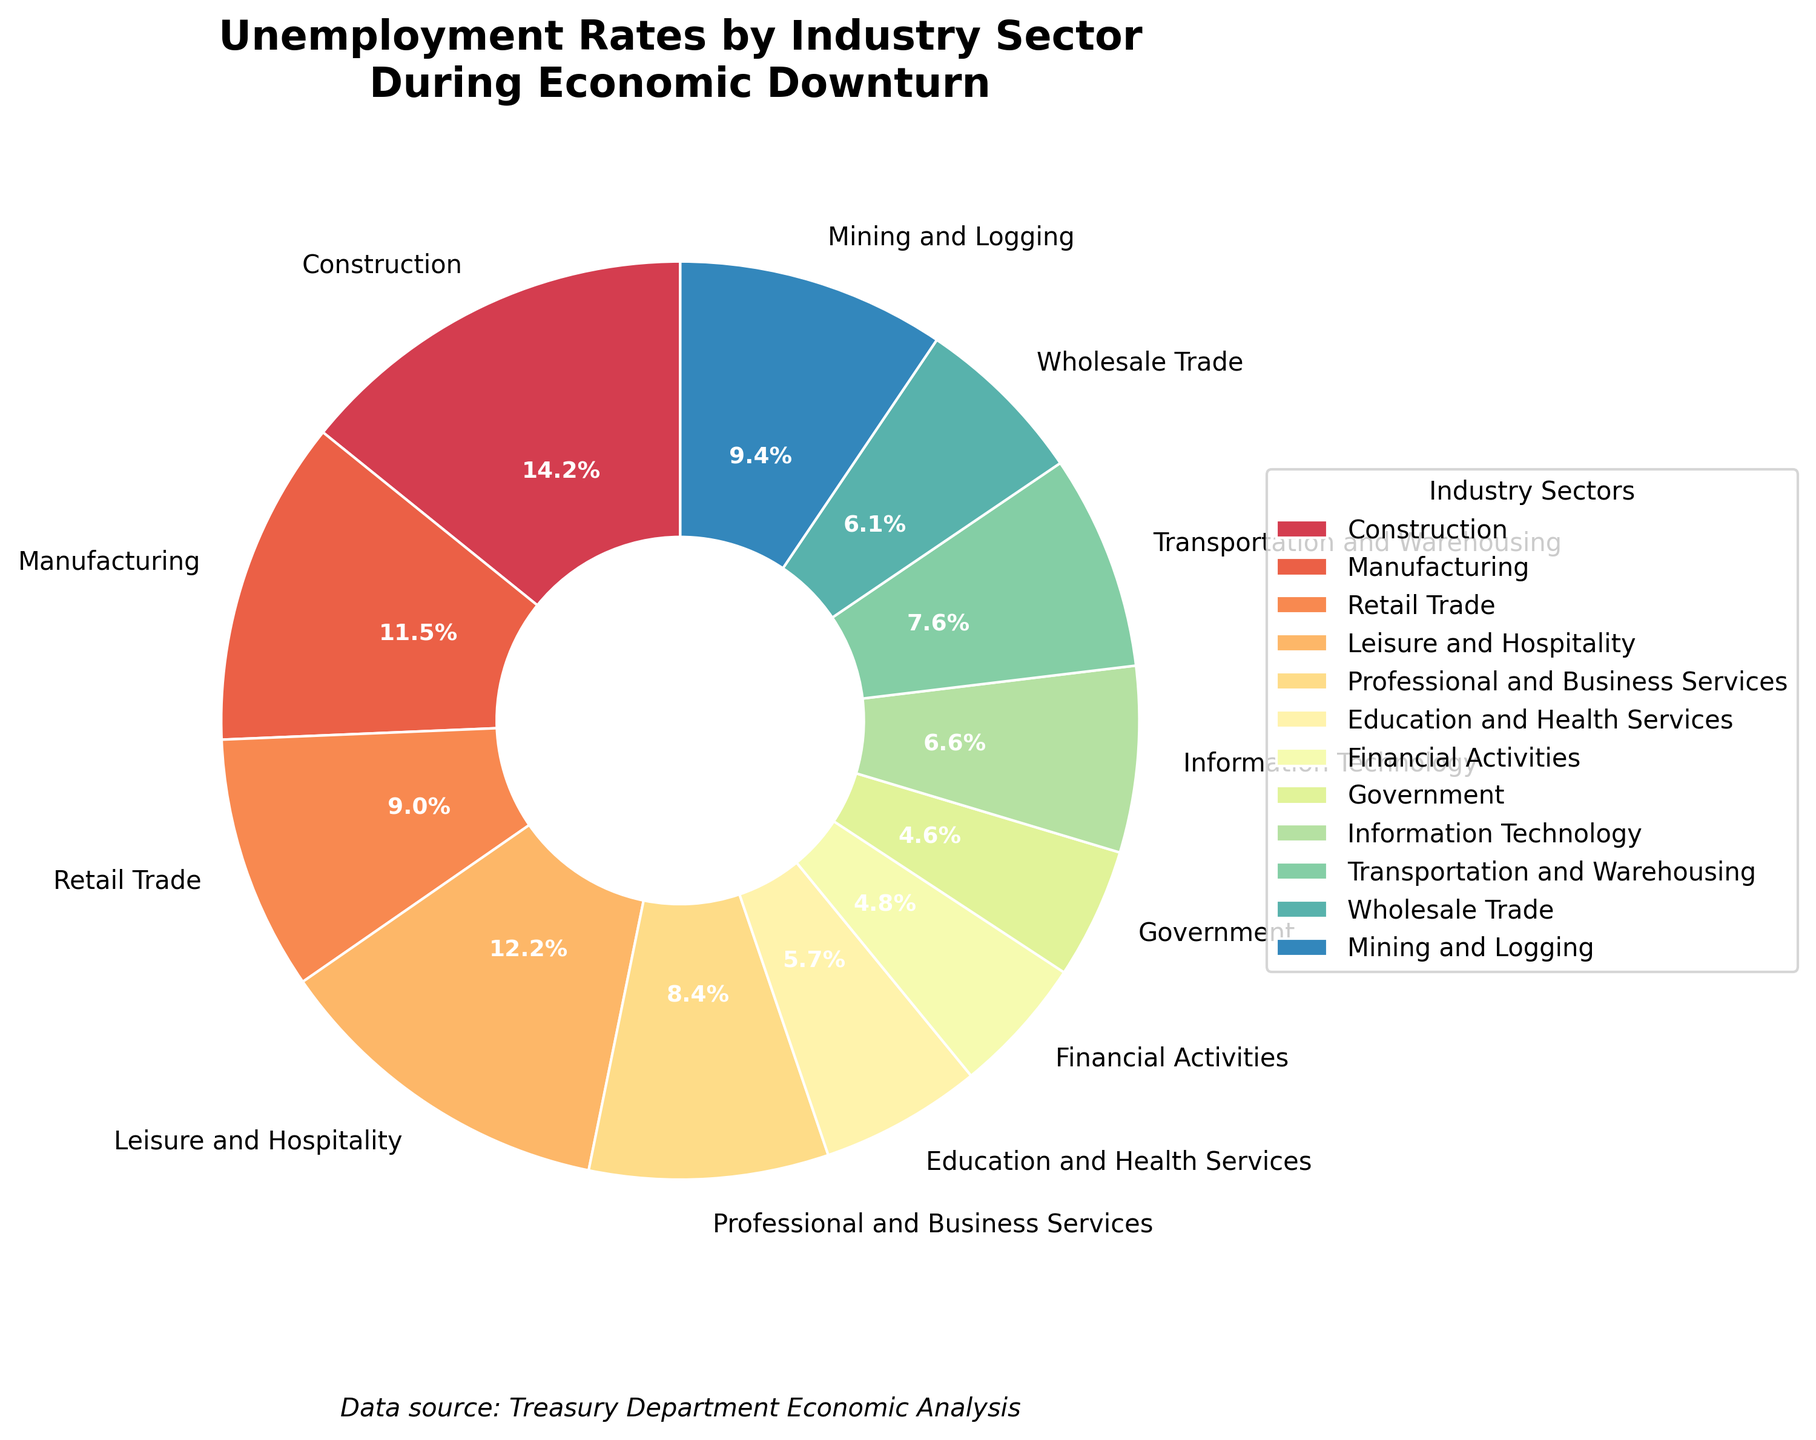What industry sector has the highest unemployment rate? Look at the pie chart and find the sector with the largest percentage. Construction has an 18.2% unemployment rate, which is the highest.
Answer: Construction What is the combined unemployment rate of the sectors with rates lower than 10%? Identify the sectors with unemployment rates lower than 10%: Education and Health Services (7.3%), Financial Activities (6.2%), Government (5.9%), Information Technology (8.4%), Transportation and Warehousing (9.7%), Wholesale Trade (7.8%). Add these rates: 7.3% + 6.2% + 5.9% + 8.4% + 9.7% + 7.8% = 45.3%.
Answer: 45.3% Which sector has the smallest wedge in the pie chart? By visual inspection, the smallest wedge corresponds to the sector with the lowest percentage. Government has a 5.9% unemployment rate, which is the smallest.
Answer: Government Compare the unemployment rates of Manufacturing and Retail Trade. Which one has a higher rate and by how much? Manufacturing has an unemployment rate of 14.7%, while Retail Trade has 11.5%. The difference is 14.7% - 11.5% = 3.2%.
Answer: Manufacturing has a higher rate by 3.2% Which sectors have an unemployment rate higher than the average rate across all sectors? Calculate the average rate by summing all rates and dividing by the number of sectors: (18.2 + 14.7 + 11.5 + 15.6 + 10.8 + 7.3 + 6.2 + 5.9 + 8.4 + 9.7 + 7.8 + 12.1) / 12 = 11.08%. Next, identify sectors with rates higher than 11.08%. They are: Construction (18.2%), Manufacturing (14.7%), Retail Trade (11.5%), Leisure and Hospitality (15.6%), Mining and Logging (12.1%).
Answer: Construction, Manufacturing, Retail Trade, Leisure and Hospitality, Mining and Logging How does the unemployment rate in Financial Activities compare to that in Education and Health Services? Financial Activities has an unemployment rate of 6.2%, and Education and Health Services has 7.3%. Therefore, Financial Activities has a lower unemployment rate by 7.3% - 6.2% = 1.1%.
Answer: Financial Activities is lower by 1.1% Which sector represents approximately one-tenth of the pie chart? One-tenth of the pie chart corresponds to 10%. Professional and Business Services has an unemployment rate of 10.8%, which is close to this proportion.
Answer: Professional and Business Services What is the cumulative unemployment rate of the three sectors with the highest rates? Identify the three sectors with the highest unemployment rates: Construction (18.2%), Leisure and Hospitality (15.6%), Manufacturing (14.7%). Add these rates: 18.2% + 15.6% + 14.7% = 48.5%.
Answer: 48.5% If the sectors with unemployment rates between 7% and 10% are grouped together, what would their total rate be? Identify these sectors: Education and Health Services (7.3%), Information Technology (8.4%), Transportation and Warehousing (9.7%), Wholesale Trade (7.8%). Add these rates: 7.3% + 8.4% + 9.7% + 7.8% = 33.2%.
Answer: 33.2% Compare the visual sizes of the wedges for Leisure and Hospitality and Mining and Logging. Which one is larger? Visually inspect the pie chart; the Leisure and Hospitality wedge is larger with a 15.6% unemployment rate compared to Mining and Logging's 12.1%.
Answer: Leisure and Hospitality 